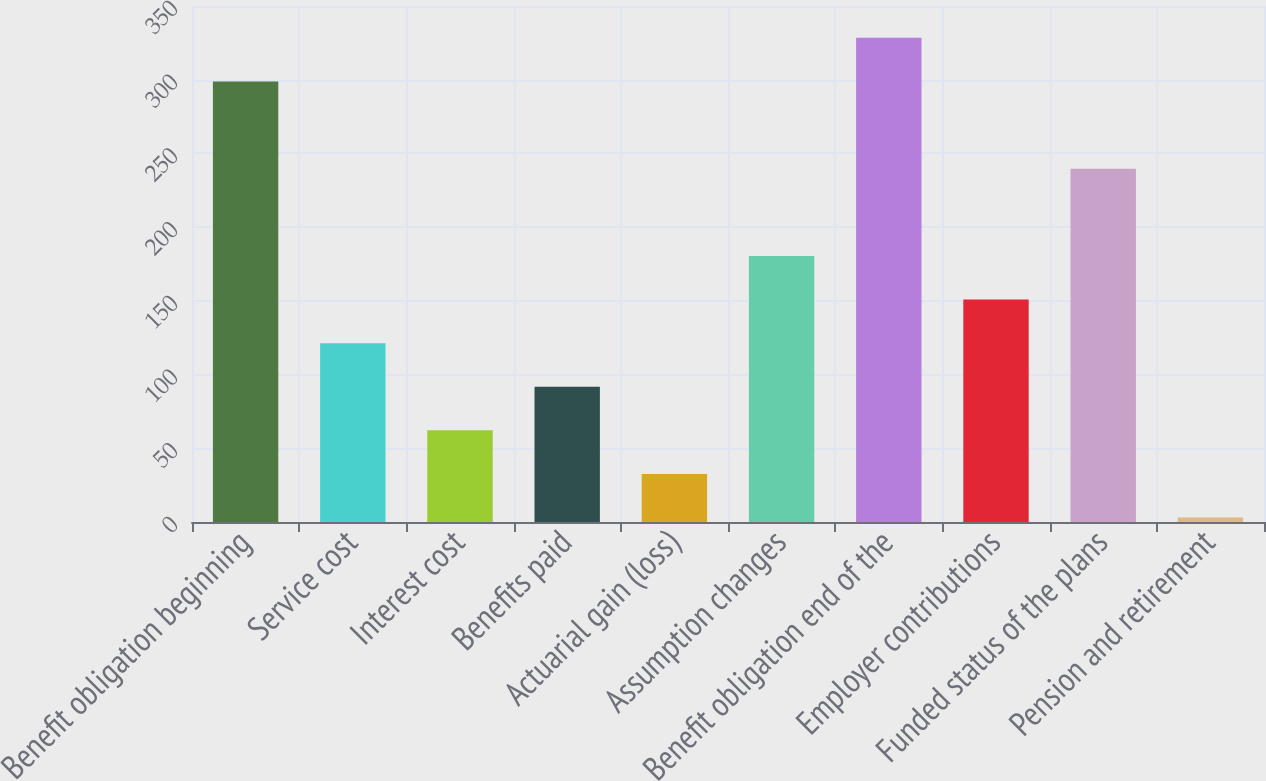<chart> <loc_0><loc_0><loc_500><loc_500><bar_chart><fcel>Benefit obligation beginning<fcel>Service cost<fcel>Interest cost<fcel>Benefits paid<fcel>Actuarial gain (loss)<fcel>Assumption changes<fcel>Benefit obligation end of the<fcel>Employer contributions<fcel>Funded status of the plans<fcel>Pension and retirement<nl><fcel>298.8<fcel>121.32<fcel>62.16<fcel>91.74<fcel>32.58<fcel>180.48<fcel>328.38<fcel>150.9<fcel>239.64<fcel>3<nl></chart> 